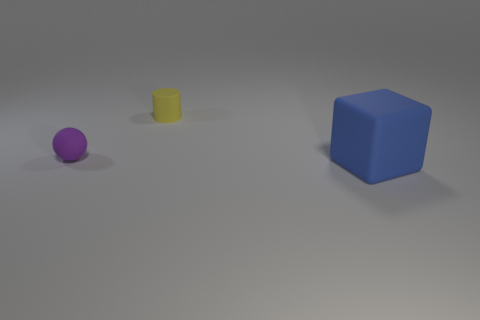Is there any symbolism associated with the arrangement of these shapes? While the current arrangement seems arbitrary, one might interpret it to represent hierarchy, with the cube's size symbolizing dominance or importance compared to the smaller sphere and cylinder. Alternatively, it could symbolize progression or growth, moving from smaller to larger objects. 